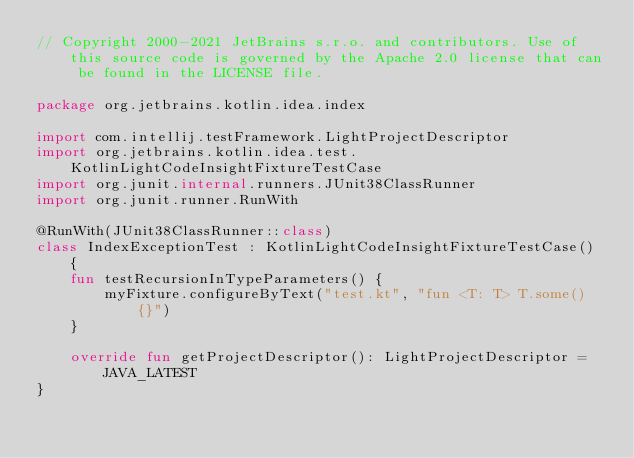Convert code to text. <code><loc_0><loc_0><loc_500><loc_500><_Kotlin_>// Copyright 2000-2021 JetBrains s.r.o. and contributors. Use of this source code is governed by the Apache 2.0 license that can be found in the LICENSE file.

package org.jetbrains.kotlin.idea.index

import com.intellij.testFramework.LightProjectDescriptor
import org.jetbrains.kotlin.idea.test.KotlinLightCodeInsightFixtureTestCase
import org.junit.internal.runners.JUnit38ClassRunner
import org.junit.runner.RunWith

@RunWith(JUnit38ClassRunner::class)
class IndexExceptionTest : KotlinLightCodeInsightFixtureTestCase() {
    fun testRecursionInTypeParameters() {
        myFixture.configureByText("test.kt", "fun <T: T> T.some() {}")
    }

    override fun getProjectDescriptor(): LightProjectDescriptor = JAVA_LATEST
}</code> 